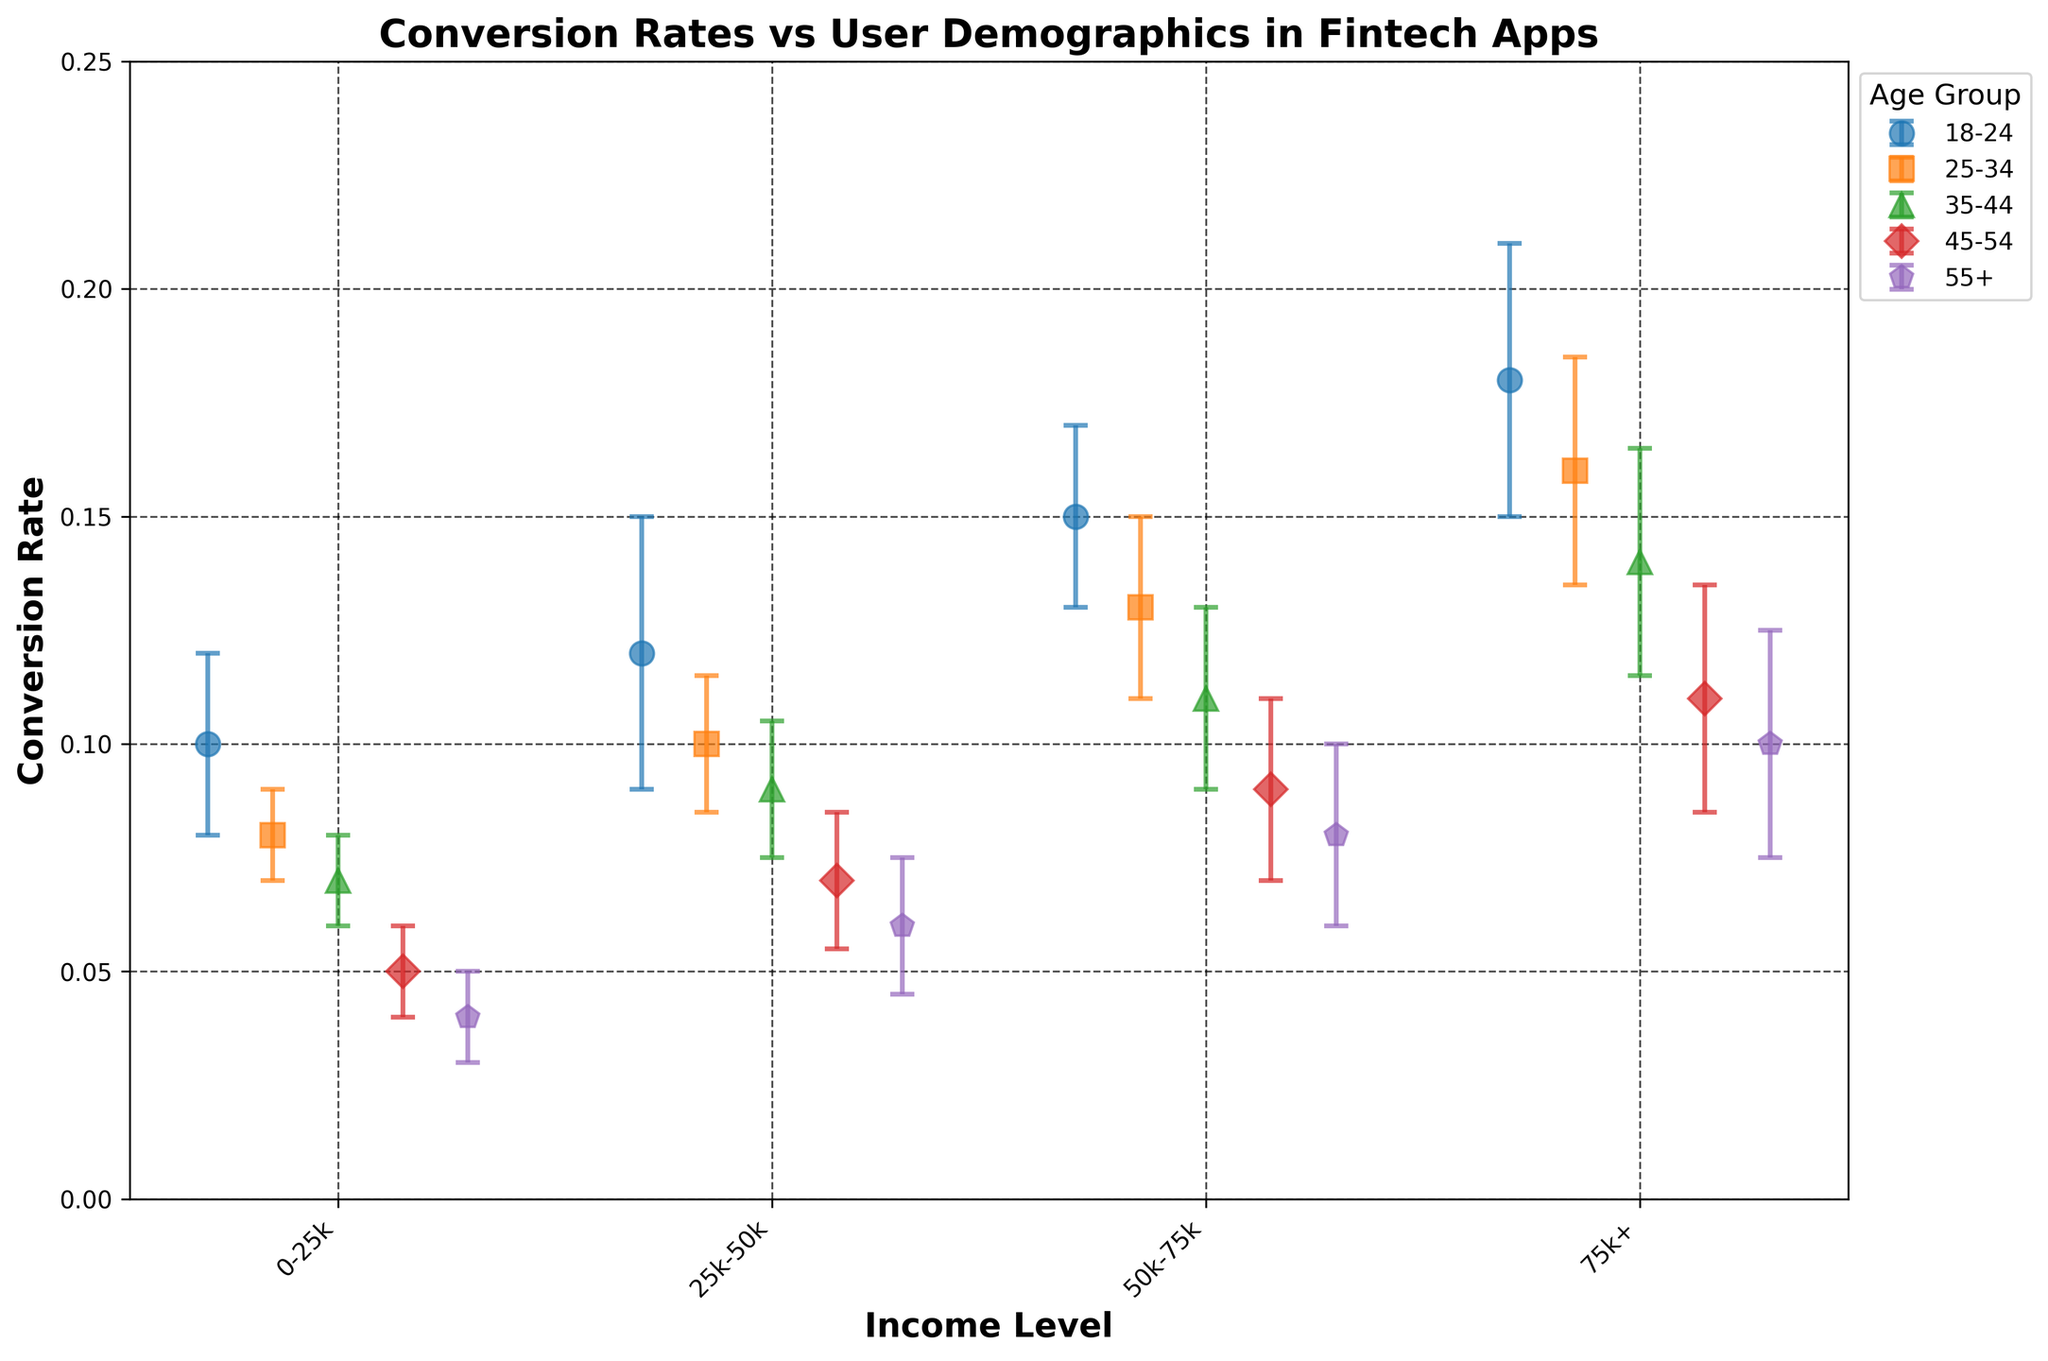what is the title of the figure? The title is usually displayed at the top of the figure in bold text. It provides a summary of what the figure represents. In this case, the title of the figure clearly indicates it is about conversion rates versus user demographics in fintech apps.
Answer: Conversion Rates vs User Demographics in Fintech Apps what are the labels of the x-axis and y-axis? The labels of the axes are generally placed right next to the axes. In this figure, the x-axis label is "Income Level" and the y-axis label is "Conversion Rate". Both labels are in bold font to make them prominent.
Answer: x-axis: Income Level, y-axis: Conversion Rate which age group shows the highest conversion rate? To determine the age group with the highest conversion rate, look for the highest data point on the y-axis across all age groups. Here, the 18-24 age group reached a conversion rate of 0.18.
Answer: 18-24 which income level generally has the lowest conversion rate for all age groups? Scan horizontally to see which income level consistently shows the lowest conversion rates across all age groups. The $0-$25k income level has the lowest conversion rates for each corresponding age group.
Answer: 0-25k what is the error margin for the conversion rate of the 25-34 age group with an income level of $50k-$75k? Identify the point that represents the 25-34 age group and the $50k-$75k income level, and then look at the error bars for that point. The error margin is represented by the yerr value, which is 0.02 in this case.
Answer: 0.02 which age group has the smallest error margin across all income levels? Evaluate the error margins for each data point within each age group. The 35-44 age group has error margins of 0.01, 0.015, 0.02, and 0.025, which doesn't have the smallest error margin for all, but the 25-34 age group has both 0.01 and 0.015 indicating smaller margins.
Answer: 25-34 compare the conversion rates for the 55+ age group and the 18-24 age group at the 75k+ income level. Locate the conversion rates for the 75k+ income level for both age groups. The 18-24 age group has a conversion rate of 0.18, while the 55+ age group has a conversion rate of 0.10.
Answer: 0.18 (18-24) vs 0.10 (55+) which age group shows the most significant increase in conversion rates from the 0-25k income level to the 75k+ income level? Calculate the increase in conversion rates from the $0-$25k income level to the $75k+ income level for each age group: 18-24: 0.18 - 0.10 = 0.08, 25-34: 0.16 - 0.08 = 0.08, 35-44: 0.14 - 0.07 = 0.07, 45-54: 0.11 - 0.05 = 0.06, and 55+: 0.10 - 0.04 = 0.06. Both 18-24 and 25-34 show the most significant increase.
Answer: 18-24 and 25-34 which income group shows the least variability in conversion rates across all age groups? The least variability would be indicated by the smallest error margins across data points. Comparing error margins horizontally for each income group, the $0-$25k income group has consistently small error margins of 0.01 across age groups.
Answer: 0-25k 